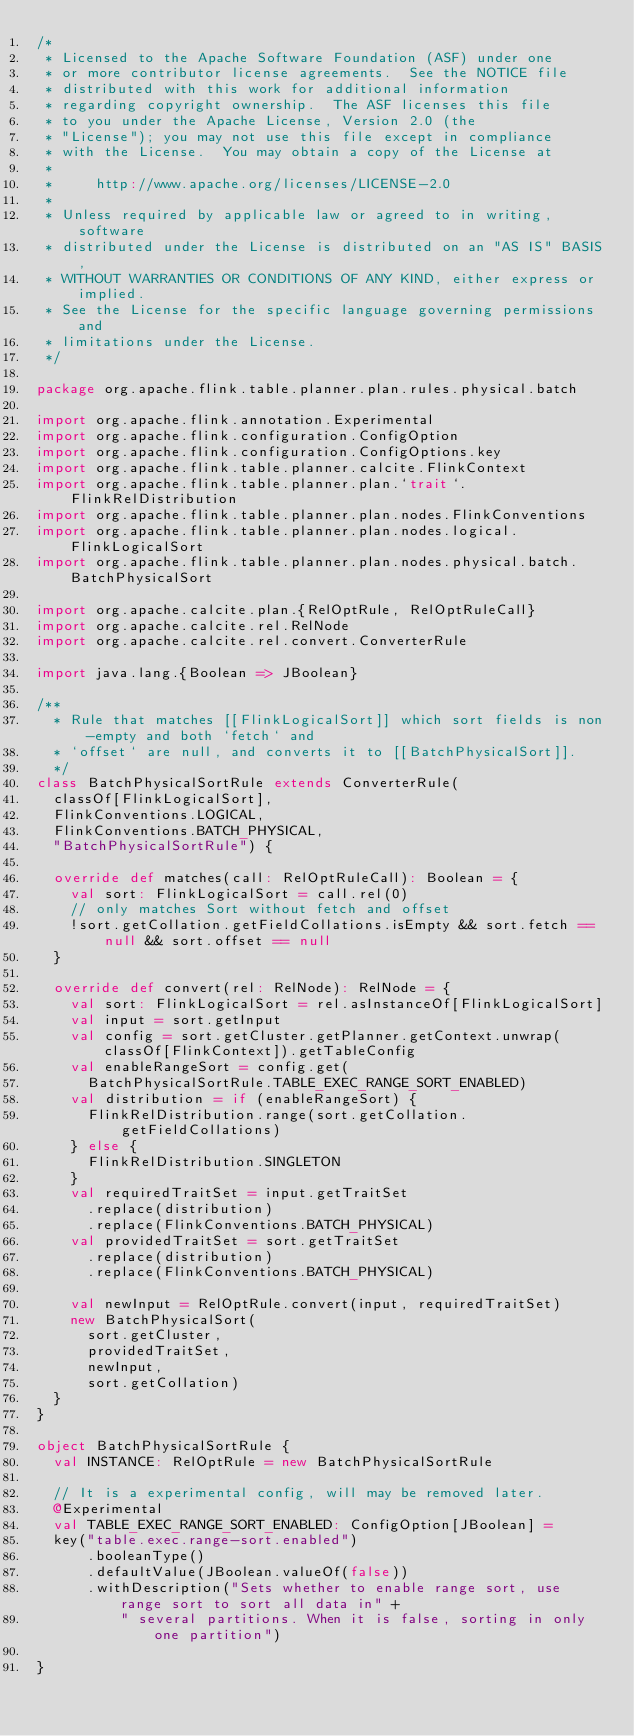<code> <loc_0><loc_0><loc_500><loc_500><_Scala_>/*
 * Licensed to the Apache Software Foundation (ASF) under one
 * or more contributor license agreements.  See the NOTICE file
 * distributed with this work for additional information
 * regarding copyright ownership.  The ASF licenses this file
 * to you under the Apache License, Version 2.0 (the
 * "License"); you may not use this file except in compliance
 * with the License.  You may obtain a copy of the License at
 *
 *     http://www.apache.org/licenses/LICENSE-2.0
 *
 * Unless required by applicable law or agreed to in writing, software
 * distributed under the License is distributed on an "AS IS" BASIS,
 * WITHOUT WARRANTIES OR CONDITIONS OF ANY KIND, either express or implied.
 * See the License for the specific language governing permissions and
 * limitations under the License.
 */

package org.apache.flink.table.planner.plan.rules.physical.batch

import org.apache.flink.annotation.Experimental
import org.apache.flink.configuration.ConfigOption
import org.apache.flink.configuration.ConfigOptions.key
import org.apache.flink.table.planner.calcite.FlinkContext
import org.apache.flink.table.planner.plan.`trait`.FlinkRelDistribution
import org.apache.flink.table.planner.plan.nodes.FlinkConventions
import org.apache.flink.table.planner.plan.nodes.logical.FlinkLogicalSort
import org.apache.flink.table.planner.plan.nodes.physical.batch.BatchPhysicalSort

import org.apache.calcite.plan.{RelOptRule, RelOptRuleCall}
import org.apache.calcite.rel.RelNode
import org.apache.calcite.rel.convert.ConverterRule

import java.lang.{Boolean => JBoolean}

/**
  * Rule that matches [[FlinkLogicalSort]] which sort fields is non-empty and both `fetch` and
  * `offset` are null, and converts it to [[BatchPhysicalSort]].
  */
class BatchPhysicalSortRule extends ConverterRule(
  classOf[FlinkLogicalSort],
  FlinkConventions.LOGICAL,
  FlinkConventions.BATCH_PHYSICAL,
  "BatchPhysicalSortRule") {

  override def matches(call: RelOptRuleCall): Boolean = {
    val sort: FlinkLogicalSort = call.rel(0)
    // only matches Sort without fetch and offset
    !sort.getCollation.getFieldCollations.isEmpty && sort.fetch == null && sort.offset == null
  }

  override def convert(rel: RelNode): RelNode = {
    val sort: FlinkLogicalSort = rel.asInstanceOf[FlinkLogicalSort]
    val input = sort.getInput
    val config = sort.getCluster.getPlanner.getContext.unwrap(classOf[FlinkContext]).getTableConfig
    val enableRangeSort = config.get(
      BatchPhysicalSortRule.TABLE_EXEC_RANGE_SORT_ENABLED)
    val distribution = if (enableRangeSort) {
      FlinkRelDistribution.range(sort.getCollation.getFieldCollations)
    } else {
      FlinkRelDistribution.SINGLETON
    }
    val requiredTraitSet = input.getTraitSet
      .replace(distribution)
      .replace(FlinkConventions.BATCH_PHYSICAL)
    val providedTraitSet = sort.getTraitSet
      .replace(distribution)
      .replace(FlinkConventions.BATCH_PHYSICAL)

    val newInput = RelOptRule.convert(input, requiredTraitSet)
    new BatchPhysicalSort(
      sort.getCluster,
      providedTraitSet,
      newInput,
      sort.getCollation)
  }
}

object BatchPhysicalSortRule {
  val INSTANCE: RelOptRule = new BatchPhysicalSortRule

  // It is a experimental config, will may be removed later.
  @Experimental
  val TABLE_EXEC_RANGE_SORT_ENABLED: ConfigOption[JBoolean] =
  key("table.exec.range-sort.enabled")
      .booleanType()
      .defaultValue(JBoolean.valueOf(false))
      .withDescription("Sets whether to enable range sort, use range sort to sort all data in" +
          " several partitions. When it is false, sorting in only one partition")

}
</code> 